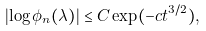<formula> <loc_0><loc_0><loc_500><loc_500>\left | \log { \phi _ { n } ( \lambda ) } \right | \leq C \exp ( - c t ^ { 3 / 2 } ) ,</formula> 